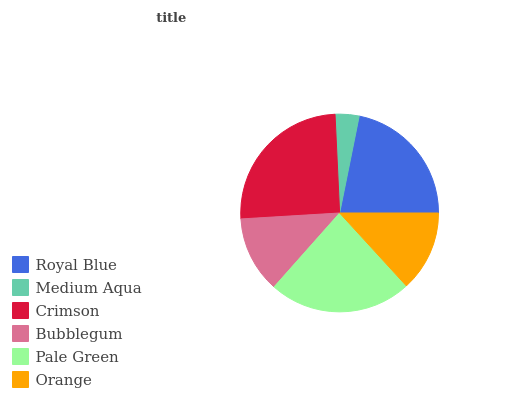Is Medium Aqua the minimum?
Answer yes or no. Yes. Is Crimson the maximum?
Answer yes or no. Yes. Is Crimson the minimum?
Answer yes or no. No. Is Medium Aqua the maximum?
Answer yes or no. No. Is Crimson greater than Medium Aqua?
Answer yes or no. Yes. Is Medium Aqua less than Crimson?
Answer yes or no. Yes. Is Medium Aqua greater than Crimson?
Answer yes or no. No. Is Crimson less than Medium Aqua?
Answer yes or no. No. Is Royal Blue the high median?
Answer yes or no. Yes. Is Orange the low median?
Answer yes or no. Yes. Is Orange the high median?
Answer yes or no. No. Is Crimson the low median?
Answer yes or no. No. 